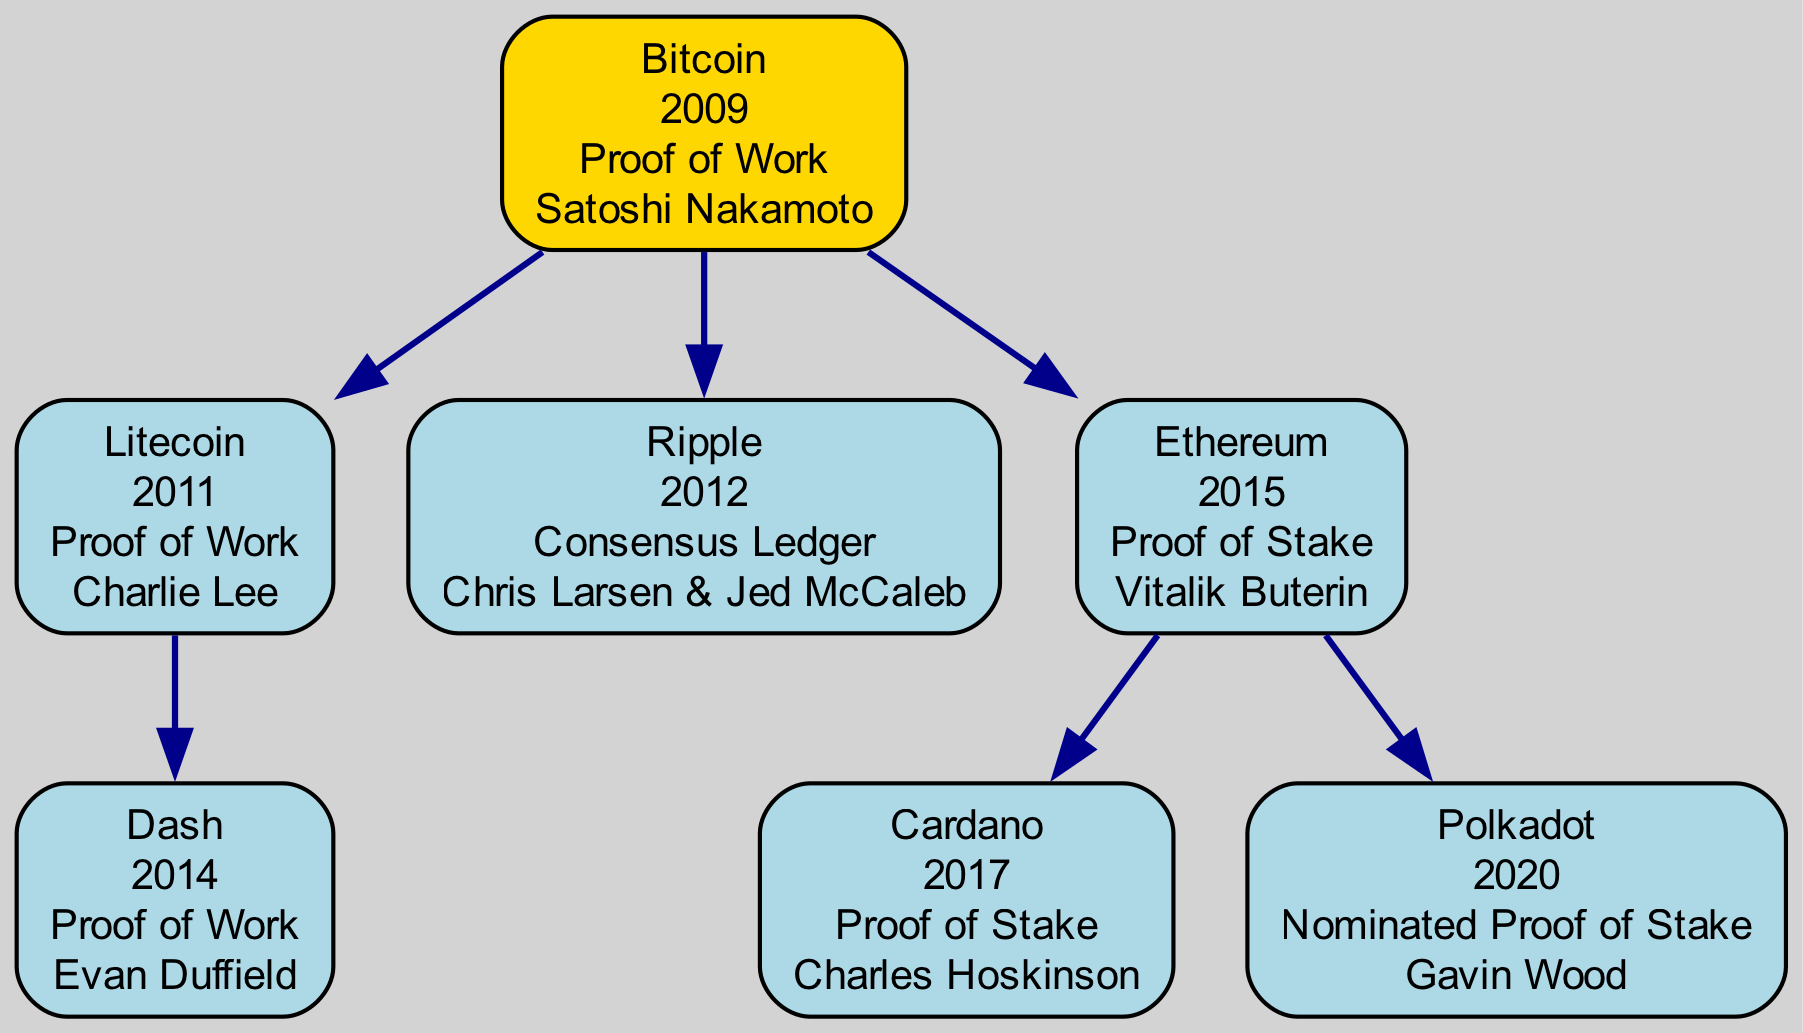What year was Bitcoin created? The diagram indicates that Bitcoin is the "Genesis" cryptocurrency, and it is listed with the year "2009" next to its name.
Answer: 2009 Who is the founder of Ethereum? Looking at the "SecondGen" section of the diagram, the node for Ethereum clearly states that its founder is "Vitalik Buterin."
Answer: Vitalik Buterin Which cryptocurrency has a "parent" relationship with Dash? In the "SecondGen" section, Dash has its parent listed as Litecoin, which is specified in the node for Dash.
Answer: Litecoin How many nodes are in the FirstGen category? The "FirstGen" category contains two cryptocurrencies: Litecoin and Ripple, both reflected in the diagram under this section.
Answer: 2 What type of consensus mechanism does Polkadot use? In the "ThirdGen" section, the Polkadot node indicates that it uses a "Nominated Proof of Stake" type of mechanism.
Answer: Nominated Proof of Stake Which cryptocurrency is a child of Bitcoin? In the diagram, both Litecoin and Ripple are branches that directly stem from the Bitcoin node, indicating that they are its children in the family tree.
Answer: Litecoin, Ripple What type of cryptocurrency is Dash? From the "SecondGen" section, Dash is categorized as "Proof of Work," which is stated next to its name in the diagram.
Answer: Proof of Work Who founded Cardano? The diagram details Cardano's founder as "Charles Hoskinson," which is listed alongside the cryptocurrency in the "ThirdGen" section.
Answer: Charles Hoskinson Which generation does Ethereum belong to? The diagram places Ethereum in the "SecondGen" category, as indicated by its positioning in relation to Bitcoin as its parent.
Answer: SecondGen 